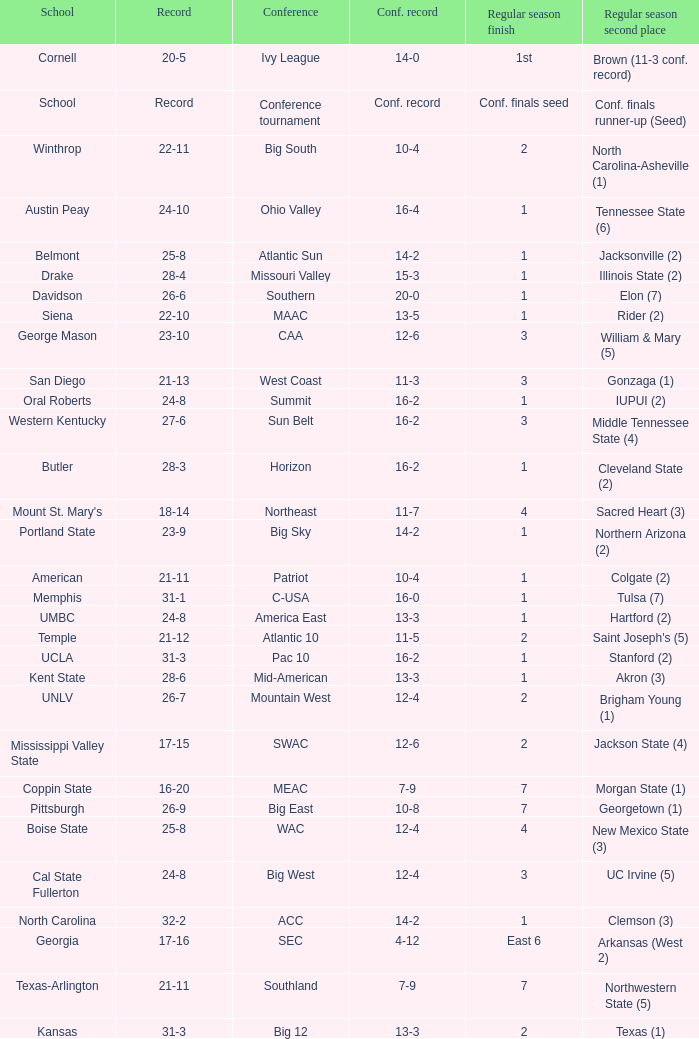What conference does belmont belong to? Atlantic Sun. 